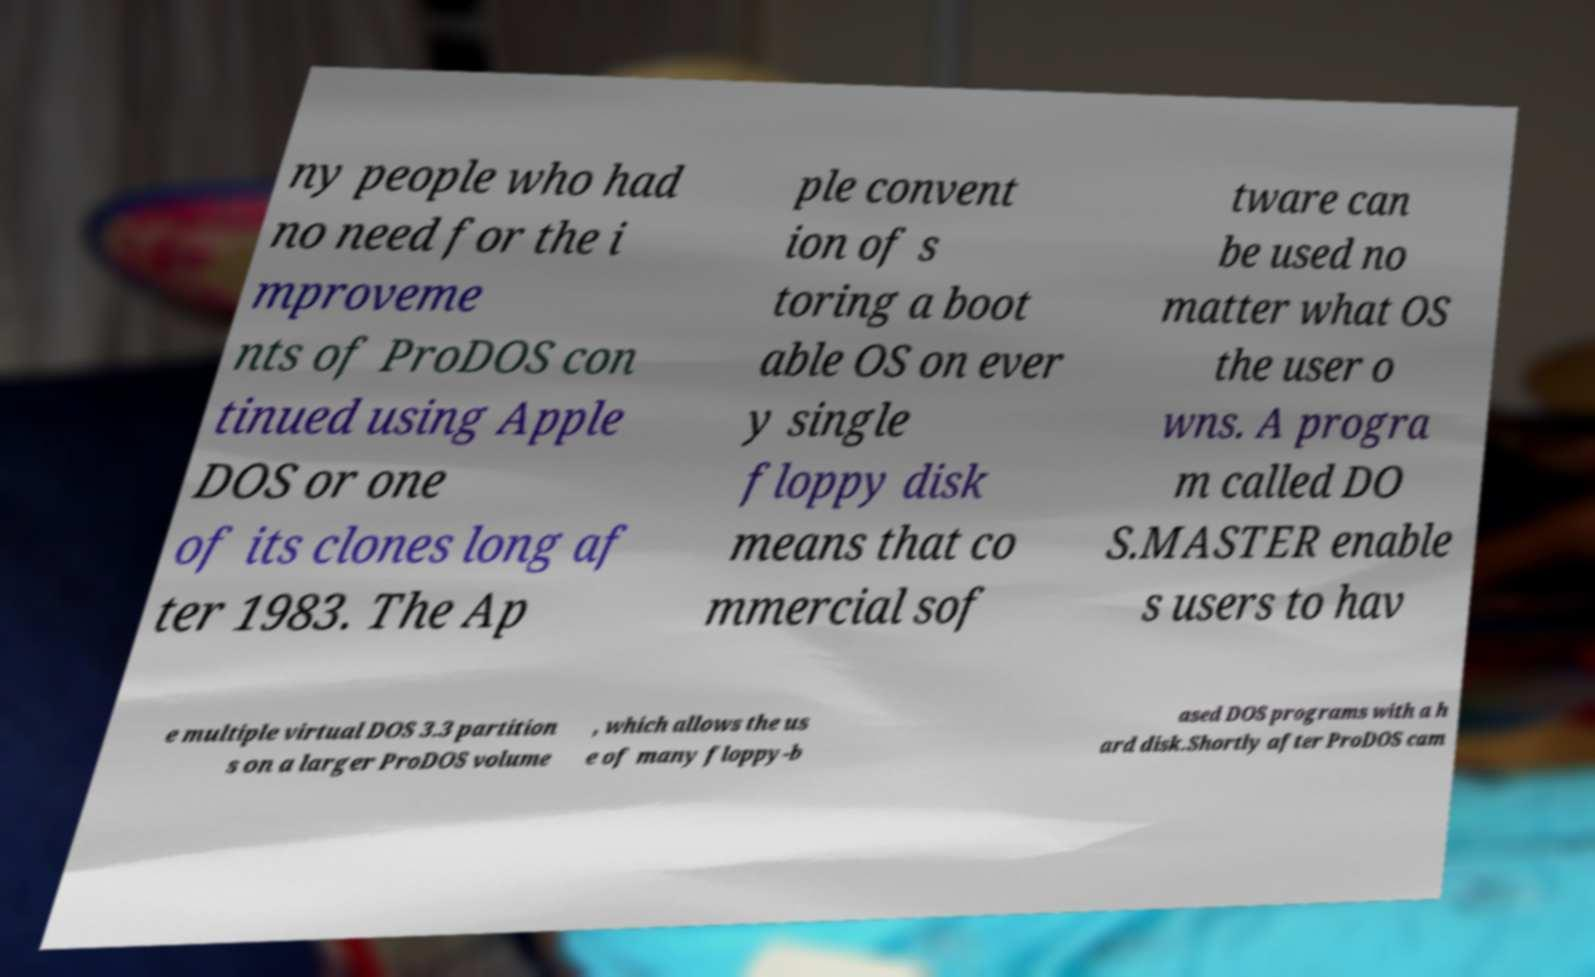Can you accurately transcribe the text from the provided image for me? ny people who had no need for the i mproveme nts of ProDOS con tinued using Apple DOS or one of its clones long af ter 1983. The Ap ple convent ion of s toring a boot able OS on ever y single floppy disk means that co mmercial sof tware can be used no matter what OS the user o wns. A progra m called DO S.MASTER enable s users to hav e multiple virtual DOS 3.3 partition s on a larger ProDOS volume , which allows the us e of many floppy-b ased DOS programs with a h ard disk.Shortly after ProDOS cam 